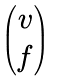Convert formula to latex. <formula><loc_0><loc_0><loc_500><loc_500>\begin{pmatrix} v \\ f \end{pmatrix}</formula> 